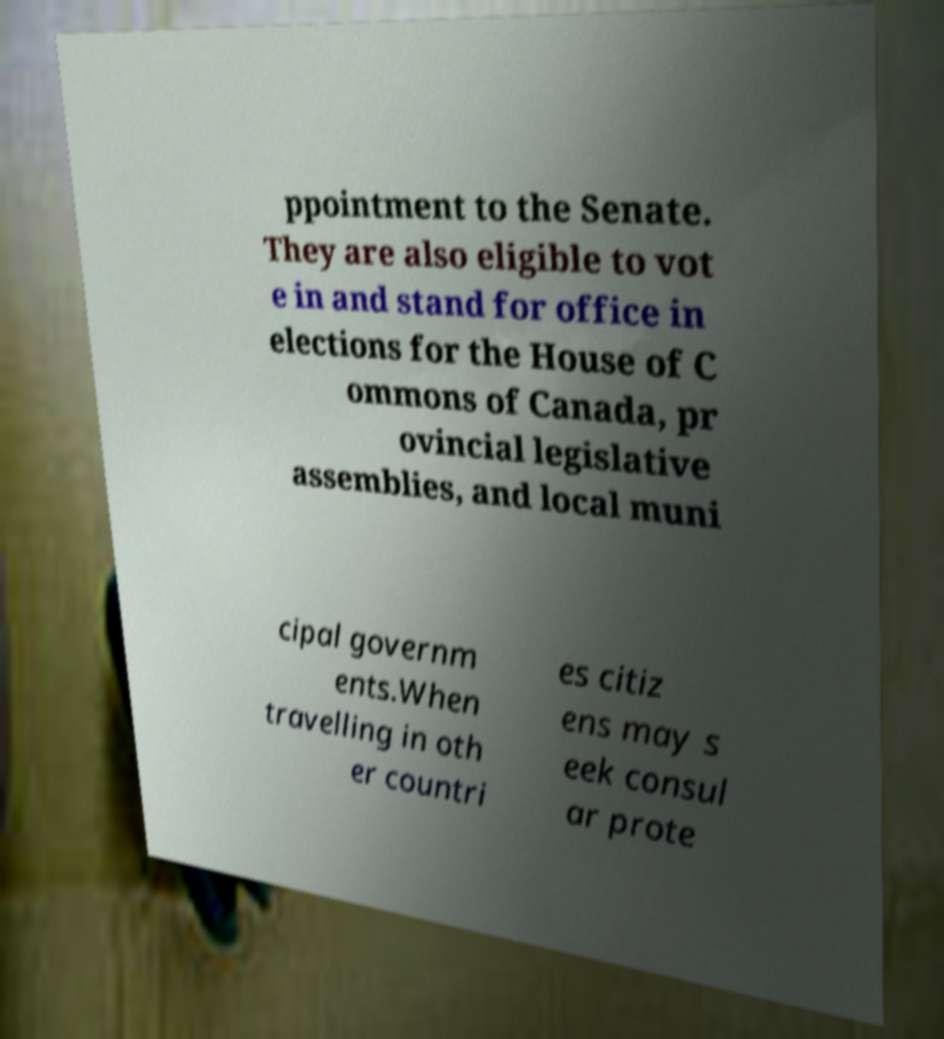What messages or text are displayed in this image? I need them in a readable, typed format. ppointment to the Senate. They are also eligible to vot e in and stand for office in elections for the House of C ommons of Canada, pr ovincial legislative assemblies, and local muni cipal governm ents.When travelling in oth er countri es citiz ens may s eek consul ar prote 